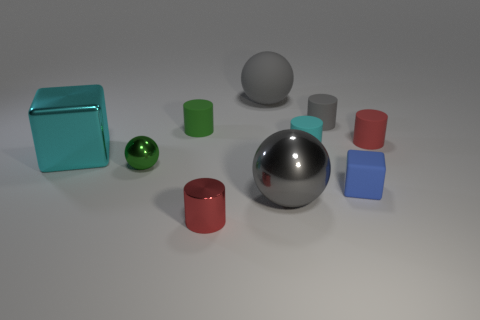Subtract all cyan cylinders. How many cylinders are left? 4 Subtract all green cylinders. How many cylinders are left? 4 Subtract all yellow cylinders. Subtract all gray spheres. How many cylinders are left? 5 Subtract all spheres. How many objects are left? 7 Subtract all tiny green spheres. Subtract all big things. How many objects are left? 6 Add 7 tiny red objects. How many tiny red objects are left? 9 Add 1 large metal things. How many large metal things exist? 3 Subtract 1 blue blocks. How many objects are left? 9 